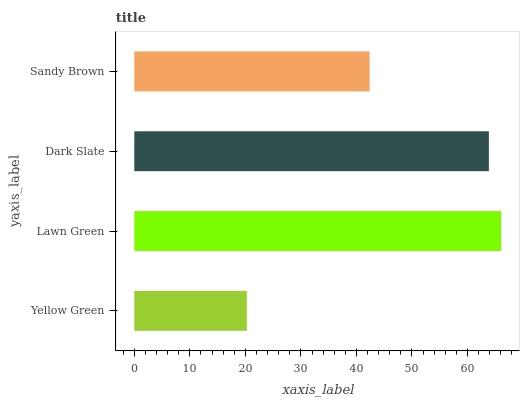Is Yellow Green the minimum?
Answer yes or no. Yes. Is Lawn Green the maximum?
Answer yes or no. Yes. Is Dark Slate the minimum?
Answer yes or no. No. Is Dark Slate the maximum?
Answer yes or no. No. Is Lawn Green greater than Dark Slate?
Answer yes or no. Yes. Is Dark Slate less than Lawn Green?
Answer yes or no. Yes. Is Dark Slate greater than Lawn Green?
Answer yes or no. No. Is Lawn Green less than Dark Slate?
Answer yes or no. No. Is Dark Slate the high median?
Answer yes or no. Yes. Is Sandy Brown the low median?
Answer yes or no. Yes. Is Sandy Brown the high median?
Answer yes or no. No. Is Lawn Green the low median?
Answer yes or no. No. 